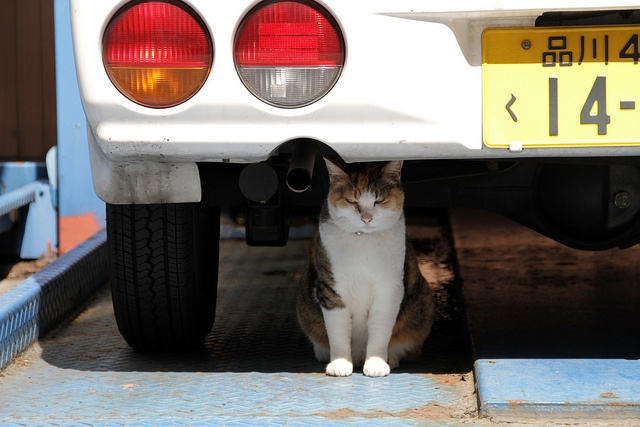Describe the objects in this image and their specific colors. I can see car in black, white, darkgray, and khaki tones and cat in black, darkgray, and gray tones in this image. 